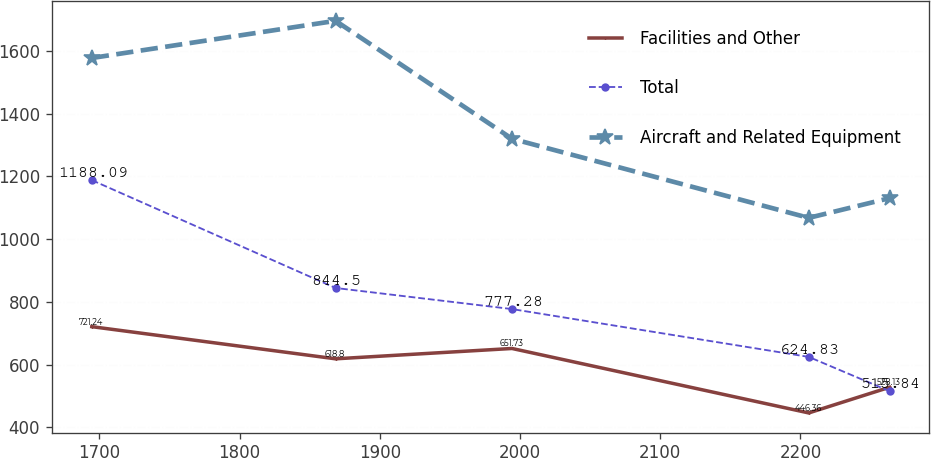<chart> <loc_0><loc_0><loc_500><loc_500><line_chart><ecel><fcel>Facilities and Other<fcel>Total<fcel>Aircraft and Related Equipment<nl><fcel>1694.67<fcel>721.24<fcel>1188.09<fcel>1577.27<nl><fcel>1868.5<fcel>618.8<fcel>844.5<fcel>1695.66<nl><fcel>1994.32<fcel>651.73<fcel>777.28<fcel>1319.93<nl><fcel>2205.93<fcel>446.36<fcel>624.83<fcel>1067.89<nl><fcel>2263.55<fcel>528.13<fcel>515.84<fcel>1130.67<nl></chart> 